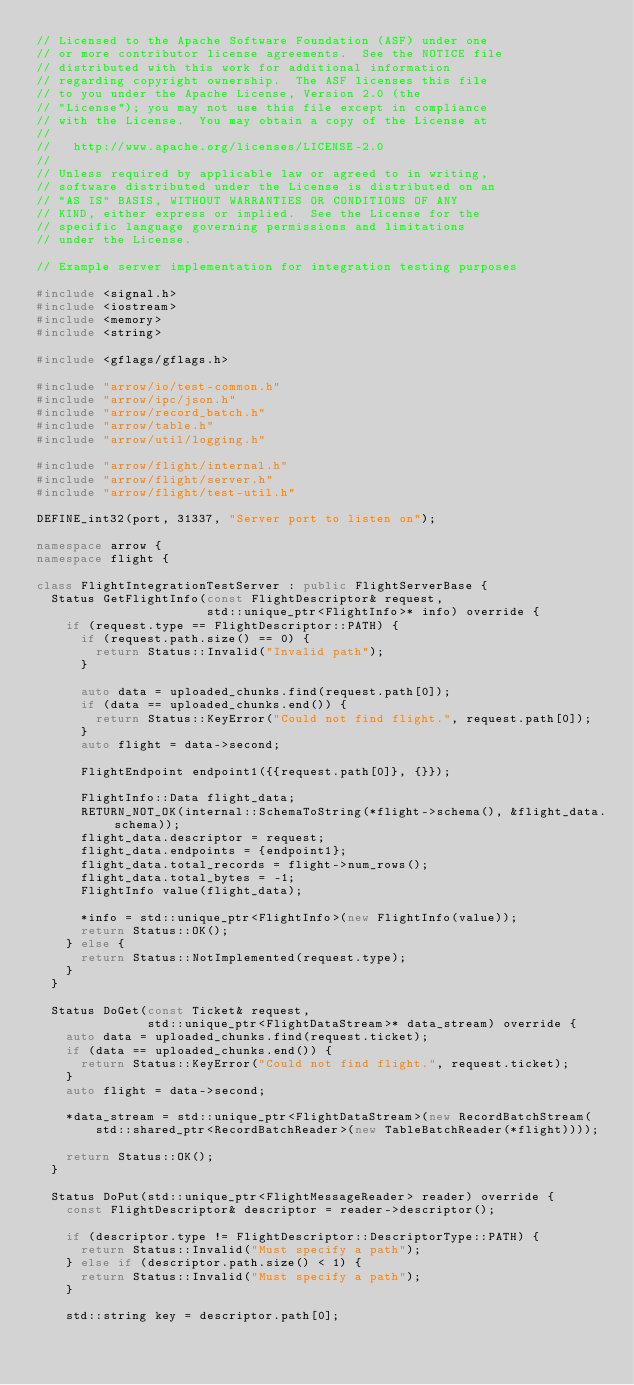Convert code to text. <code><loc_0><loc_0><loc_500><loc_500><_C++_>// Licensed to the Apache Software Foundation (ASF) under one
// or more contributor license agreements.  See the NOTICE file
// distributed with this work for additional information
// regarding copyright ownership.  The ASF licenses this file
// to you under the Apache License, Version 2.0 (the
// "License"); you may not use this file except in compliance
// with the License.  You may obtain a copy of the License at
//
//   http://www.apache.org/licenses/LICENSE-2.0
//
// Unless required by applicable law or agreed to in writing,
// software distributed under the License is distributed on an
// "AS IS" BASIS, WITHOUT WARRANTIES OR CONDITIONS OF ANY
// KIND, either express or implied.  See the License for the
// specific language governing permissions and limitations
// under the License.

// Example server implementation for integration testing purposes

#include <signal.h>
#include <iostream>
#include <memory>
#include <string>

#include <gflags/gflags.h>

#include "arrow/io/test-common.h"
#include "arrow/ipc/json.h"
#include "arrow/record_batch.h"
#include "arrow/table.h"
#include "arrow/util/logging.h"

#include "arrow/flight/internal.h"
#include "arrow/flight/server.h"
#include "arrow/flight/test-util.h"

DEFINE_int32(port, 31337, "Server port to listen on");

namespace arrow {
namespace flight {

class FlightIntegrationTestServer : public FlightServerBase {
  Status GetFlightInfo(const FlightDescriptor& request,
                       std::unique_ptr<FlightInfo>* info) override {
    if (request.type == FlightDescriptor::PATH) {
      if (request.path.size() == 0) {
        return Status::Invalid("Invalid path");
      }

      auto data = uploaded_chunks.find(request.path[0]);
      if (data == uploaded_chunks.end()) {
        return Status::KeyError("Could not find flight.", request.path[0]);
      }
      auto flight = data->second;

      FlightEndpoint endpoint1({{request.path[0]}, {}});

      FlightInfo::Data flight_data;
      RETURN_NOT_OK(internal::SchemaToString(*flight->schema(), &flight_data.schema));
      flight_data.descriptor = request;
      flight_data.endpoints = {endpoint1};
      flight_data.total_records = flight->num_rows();
      flight_data.total_bytes = -1;
      FlightInfo value(flight_data);

      *info = std::unique_ptr<FlightInfo>(new FlightInfo(value));
      return Status::OK();
    } else {
      return Status::NotImplemented(request.type);
    }
  }

  Status DoGet(const Ticket& request,
               std::unique_ptr<FlightDataStream>* data_stream) override {
    auto data = uploaded_chunks.find(request.ticket);
    if (data == uploaded_chunks.end()) {
      return Status::KeyError("Could not find flight.", request.ticket);
    }
    auto flight = data->second;

    *data_stream = std::unique_ptr<FlightDataStream>(new RecordBatchStream(
        std::shared_ptr<RecordBatchReader>(new TableBatchReader(*flight))));

    return Status::OK();
  }

  Status DoPut(std::unique_ptr<FlightMessageReader> reader) override {
    const FlightDescriptor& descriptor = reader->descriptor();

    if (descriptor.type != FlightDescriptor::DescriptorType::PATH) {
      return Status::Invalid("Must specify a path");
    } else if (descriptor.path.size() < 1) {
      return Status::Invalid("Must specify a path");
    }

    std::string key = descriptor.path[0];
</code> 